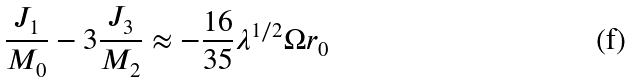Convert formula to latex. <formula><loc_0><loc_0><loc_500><loc_500>\frac { J _ { 1 } } { M _ { 0 } } - 3 \frac { J _ { 3 } } { M _ { 2 } } \approx - \frac { 1 6 } { 3 5 } \lambda ^ { 1 / 2 } \Omega r _ { 0 }</formula> 